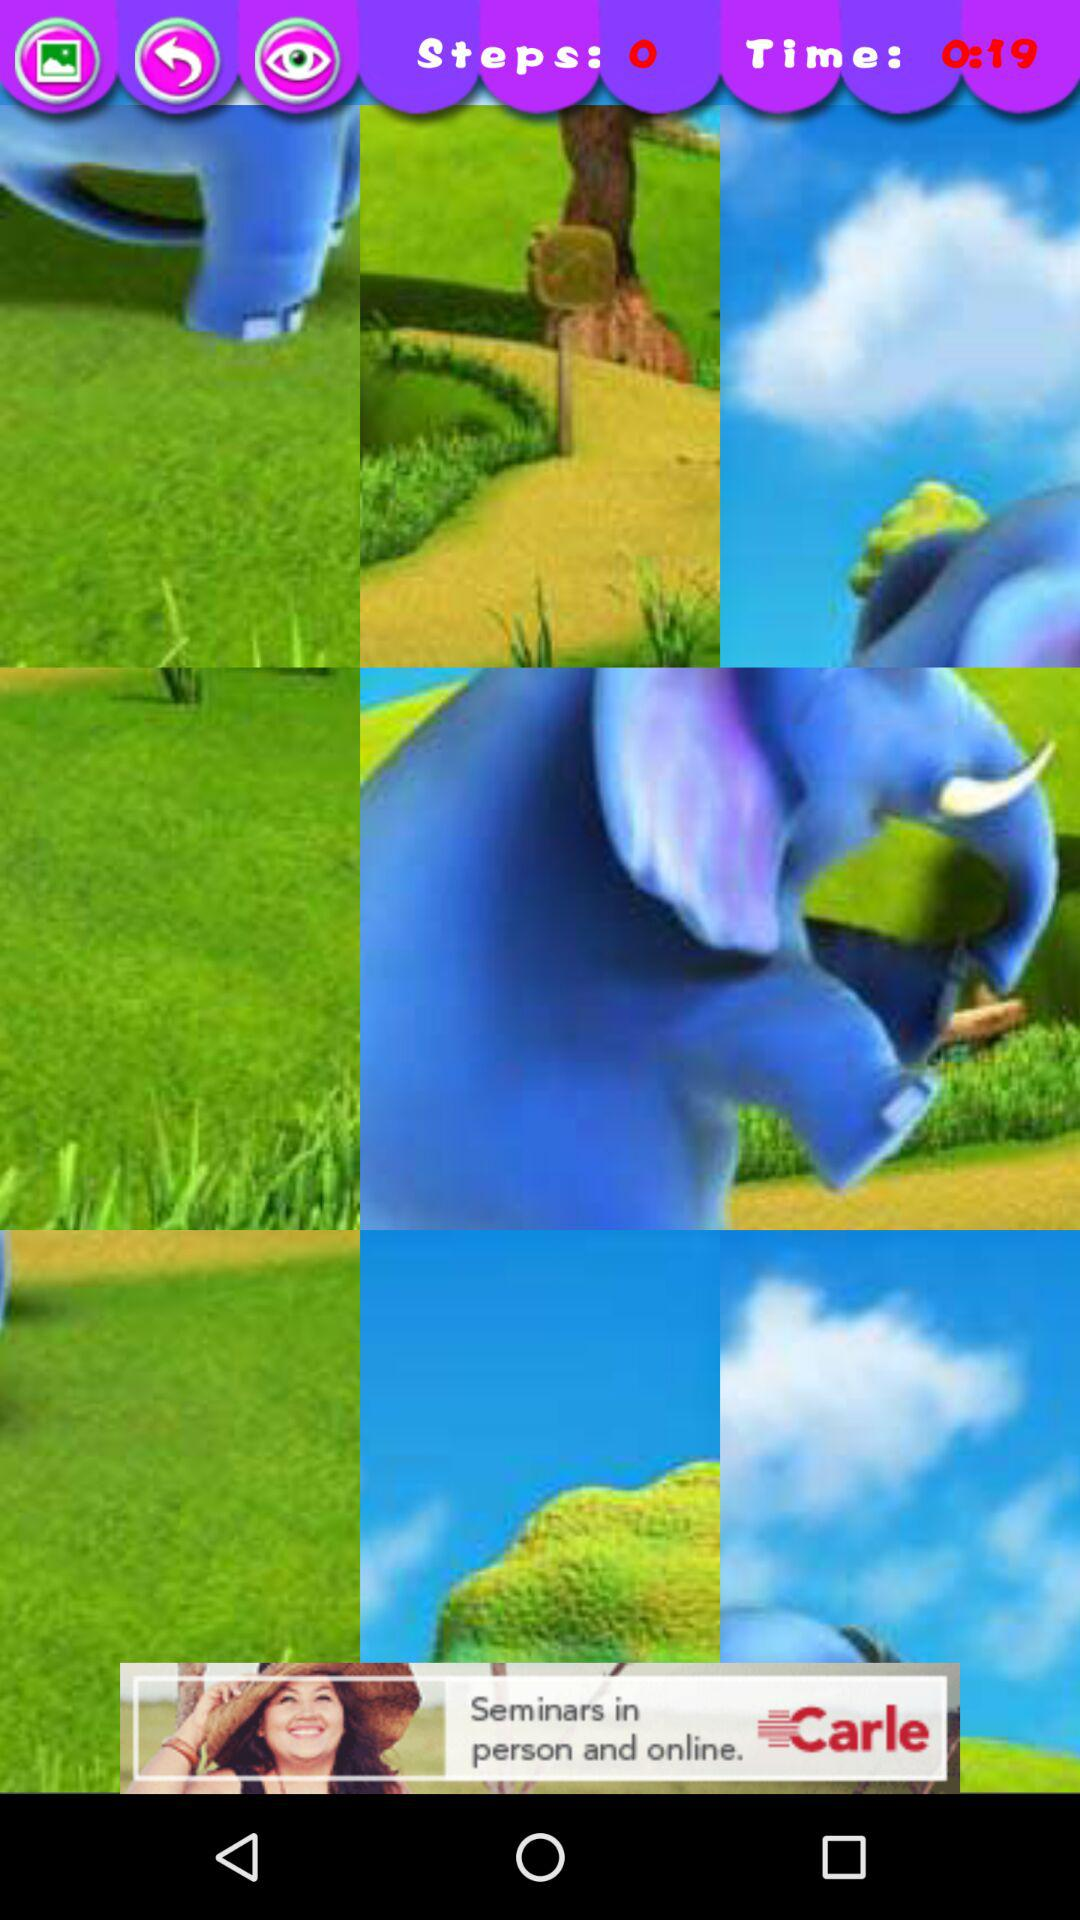How many steps are there? There are 0 steps. 